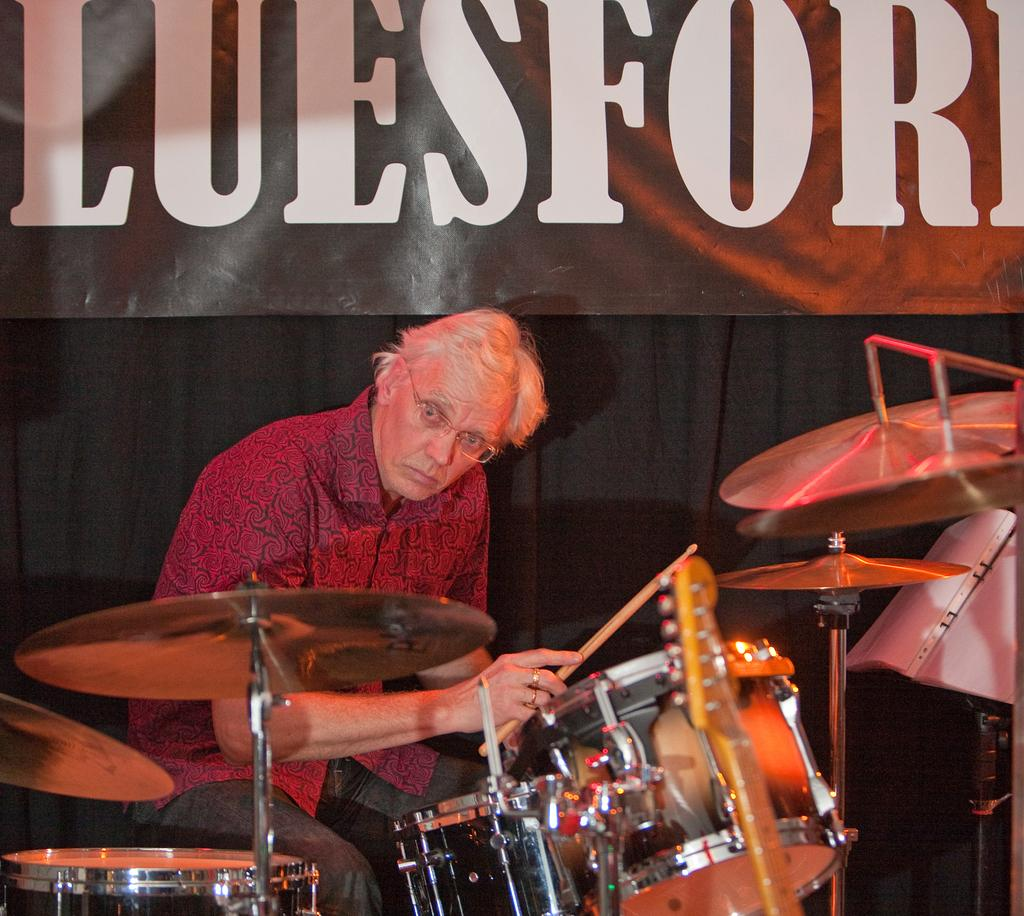Who is present in the image? There is a man in the image. What is the man doing in the image? The man is sitting near the drums. What object is the man holding in his hand? The man is holding a stick in his hand. What additional element can be seen in the image? There is a banner visible in the image. What is the man doing to celebrate the birth in the image? There is no indication of a birth or any celebration in the image; the man is simply sitting near the drums and holding a stick. 